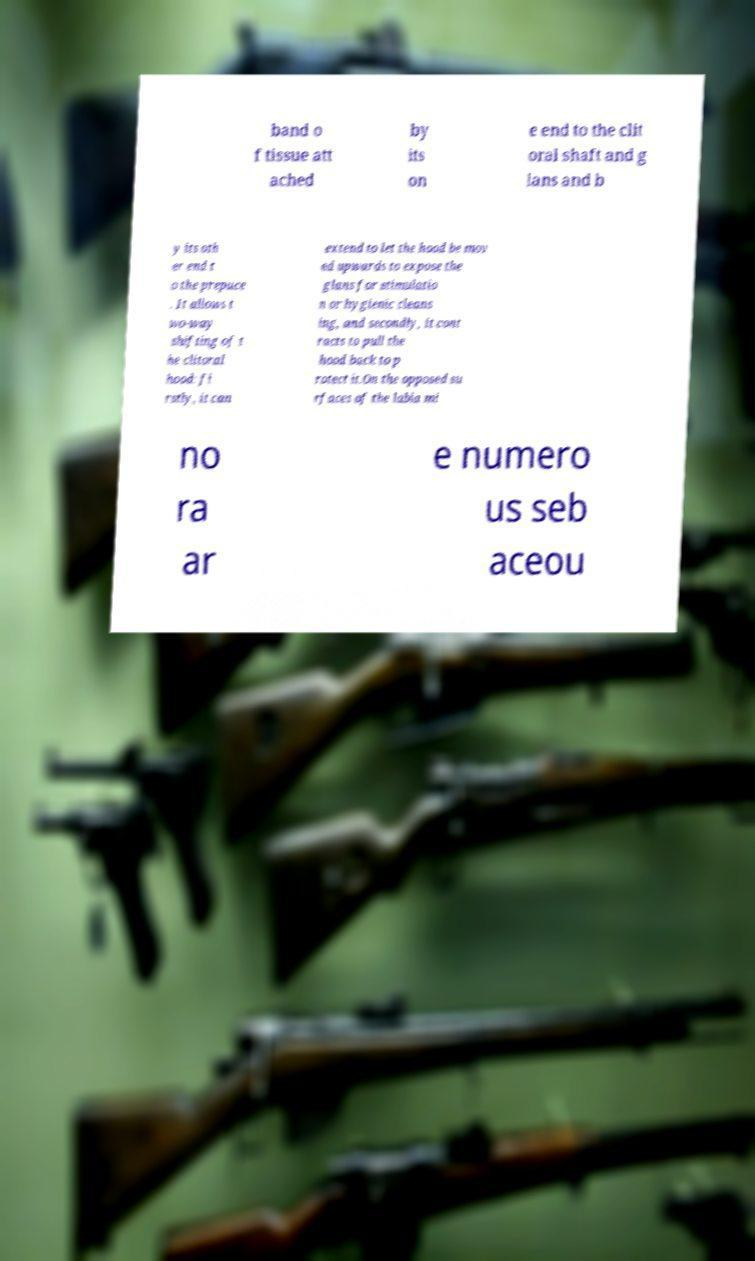I need the written content from this picture converted into text. Can you do that? band o f tissue att ached by its on e end to the clit oral shaft and g lans and b y its oth er end t o the prepuce . It allows t wo-way shifting of t he clitoral hood: fi rstly, it can extend to let the hood be mov ed upwards to expose the glans for stimulatio n or hygienic cleans ing, and secondly, it cont racts to pull the hood back to p rotect it.On the opposed su rfaces of the labia mi no ra ar e numero us seb aceou 